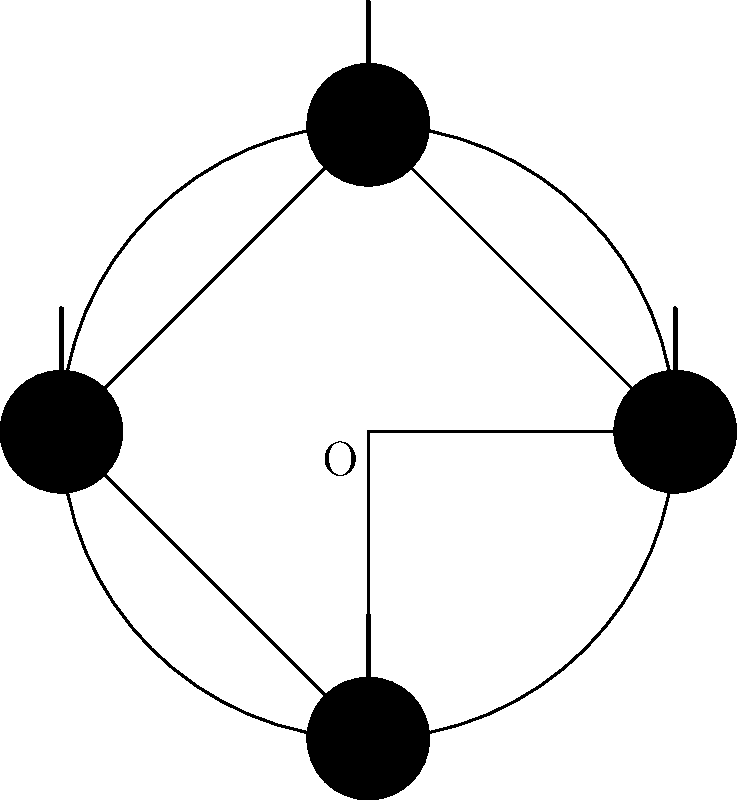As a music-loving parent, you're helping your adopted child with their geometry homework. The question involves rotating a musical note symbol around a fixed point O. If the note at point A is rotated 270° counterclockwise around O, at which point (A, B, C, or D) will it end up? Let's approach this step-by-step:

1) First, we need to understand what a 270° counterclockwise rotation means:
   - It's equivalent to a three-quarter turn in the counterclockwise direction.

2) In the diagram, we can see four positions of the musical note:
   - A: The starting position (0°)
   - B: 90° counterclockwise from A
   - C: 180° counterclockwise from A
   - D: 270° counterclockwise from A

3) To rotate 270° counterclockwise:
   - From A to B is 90°
   - From B to C is another 90° (total 180°)
   - From C to D is another 90° (total 270°)

4) Therefore, after a 270° counterclockwise rotation, the note that started at A will end up at position D.

This rotation can also be thought of as a 90° clockwise rotation, which might be easier to visualize for some people.
Answer: D 